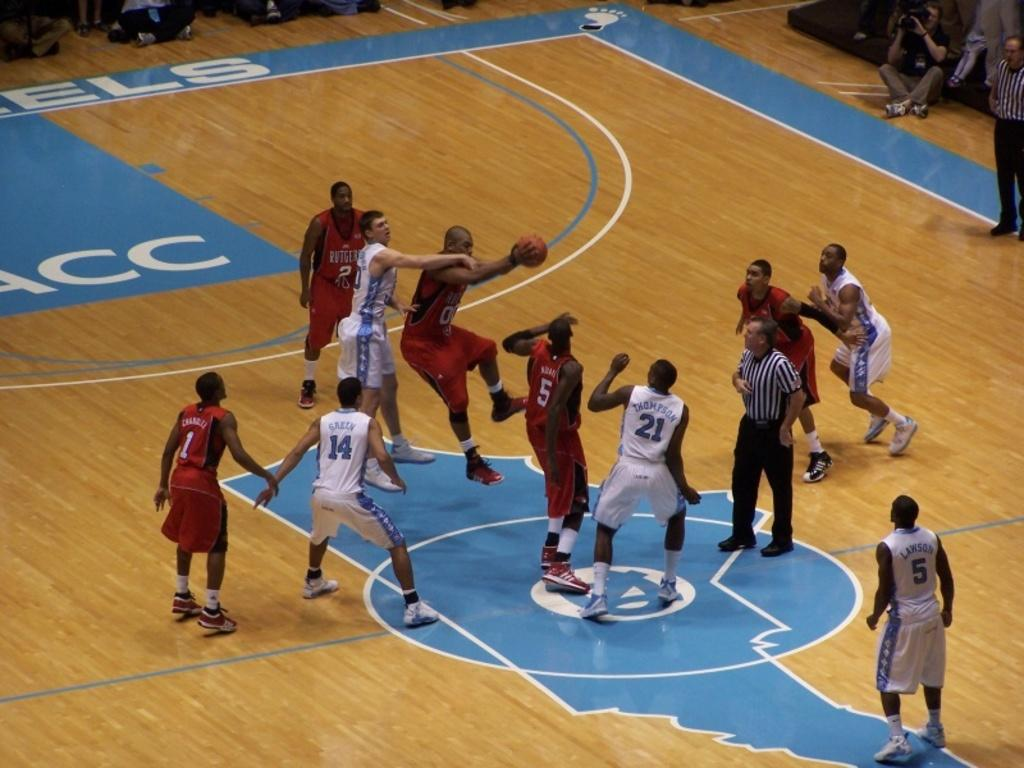What type of clothing are the people wearing in the image? The people in the image are wearing basketball attire. What colors are featured in the basketball attire? The basketball attire includes red and white shorts and t-shirts. What part of the building can be seen in the image? The bottom floor is visible in the image. Who else is present in the image besides the people wearing basketball attire? There is a man with a camera in the image. How much wealth is displayed in the image? There is no indication of wealth in the image; it features people wearing basketball attire and a man with a camera. Can you tell me how many times the person in the image bites into the basketball? There is no basketball present in the image, and therefore no biting can be observed. 